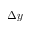<formula> <loc_0><loc_0><loc_500><loc_500>\Delta y</formula> 